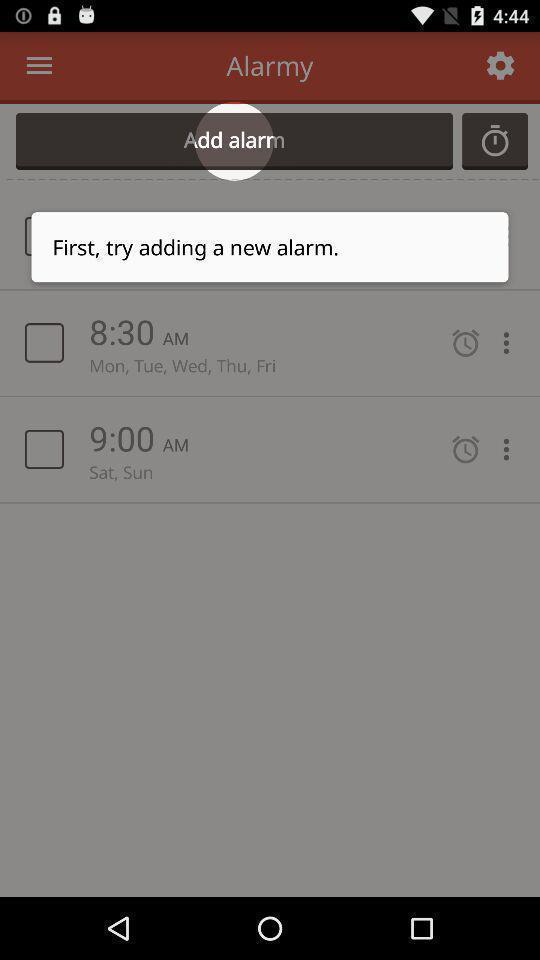What is the overall content of this screenshot? Pop up showing to add a new alarm in application. 